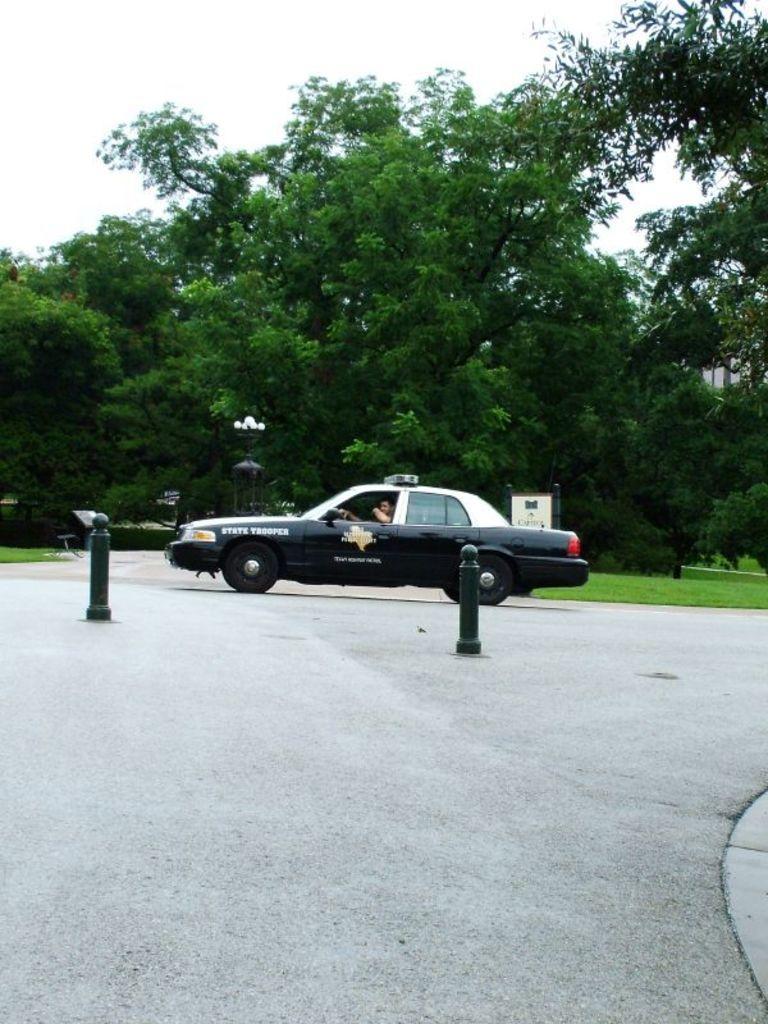In one or two sentences, can you explain what this image depicts? In the image there is a car with a man inside it on road, in front of it there are two traffic cones and behind it there are trees on the grass land and above its sky. 